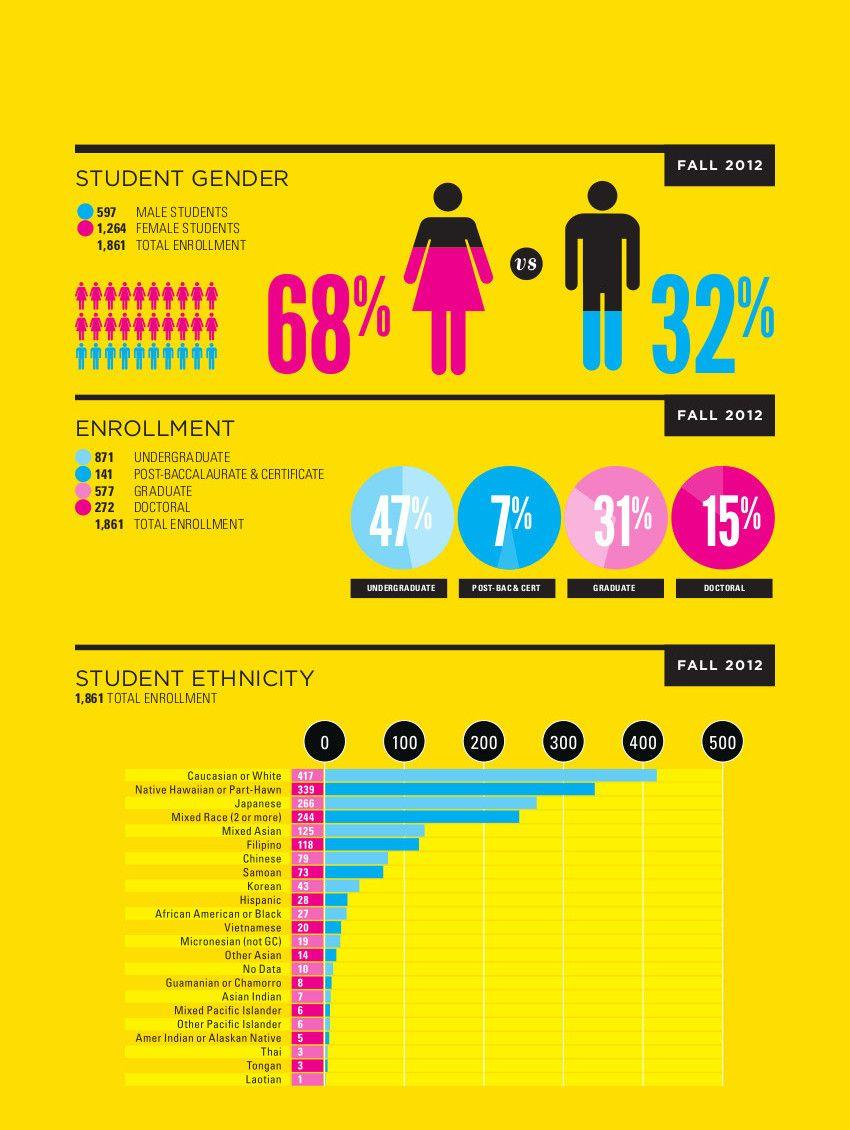Mention a couple of crucial points in this snapshot. The majority of students who enrolled during fall 2012 had an undergraduate degree. During the fall 2012, a total of 7 Asian Indian students enrolled. During fall 2012, 31% of students enrolled in a graduate degree program. During the fall 2012 semester, 68% of female students were enrolled at the university. During the fall 2012 semester, approximately 32% of enrolled male students were enrolled. 